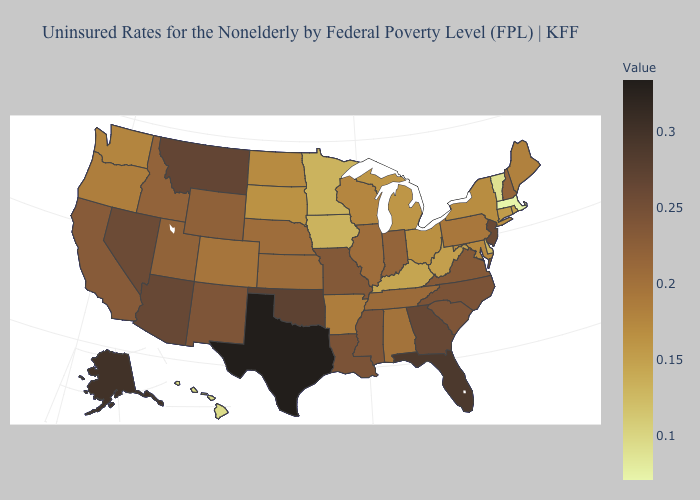Among the states that border Maryland , which have the highest value?
Keep it brief. Virginia. Which states have the lowest value in the USA?
Quick response, please. Massachusetts. Among the states that border Wyoming , does Montana have the highest value?
Be succinct. Yes. Does Texas have the highest value in the USA?
Keep it brief. Yes. Which states hav the highest value in the Northeast?
Concise answer only. New Jersey. Does Texas have the highest value in the South?
Quick response, please. Yes. Does Massachusetts have the lowest value in the USA?
Answer briefly. Yes. Which states have the highest value in the USA?
Give a very brief answer. Texas. 